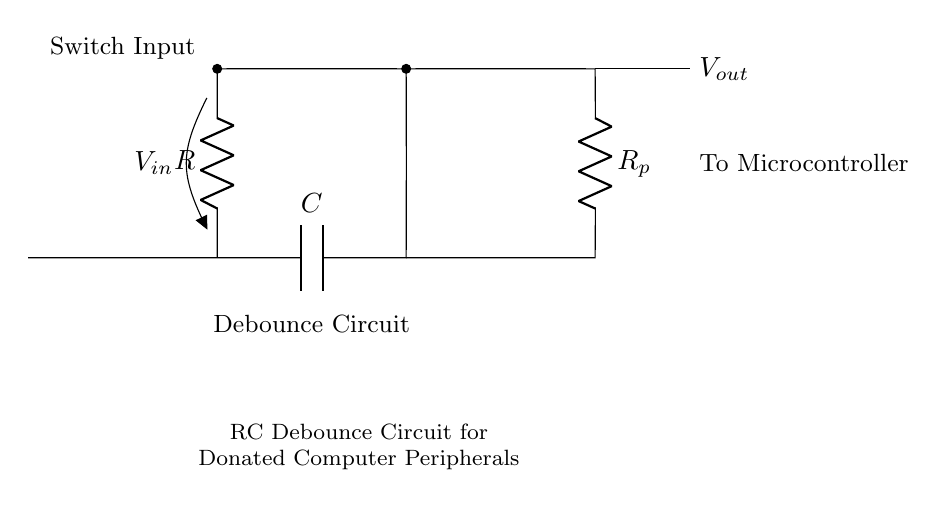What is the value of the resistor labeled "R"? The diagram does not specify a numerical value for the resistor labeled "R"; it is presented as an abstract component in the circuit.
Answer: R What connects the capacitor to the input voltage? The capacitor is connected to the input voltage through the resistor labeled "R". This connection influences the charging and discharging behavior, crucial for the debounce function.
Answer: Resistor What is the purpose of the capacitor in this circuit? The capacitor smooths out the fluctuations in the voltage signal caused by mechanical bouncing of the switch, providing a stable voltage output to the microcontroller.
Answer: Stabilization How many resistors are in this circuit? There are two resistors in total: one labeled "R" and another labeled "R_p".
Answer: Two What is the output voltage referenced as? The output voltage is referenced as "V_out", which is the voltage delivered to the microcontroller after passing through the debounce circuit.
Answer: V_out Why is the switch input noted in the diagram? The switch input is marked because it triggers the circuit, and its mechanical bouncing can introduce noise that the debounce circuit is designed to filter out.
Answer: To filter noise What does “R_p” signify in the context of this circuit? "R_p" represents a pull-down resistor; it ensures that the output voltage "V_out" stabilizes at 0V when the switch is open, helping to define a clear state for the microcontroller.
Answer: Pull-down resistor 